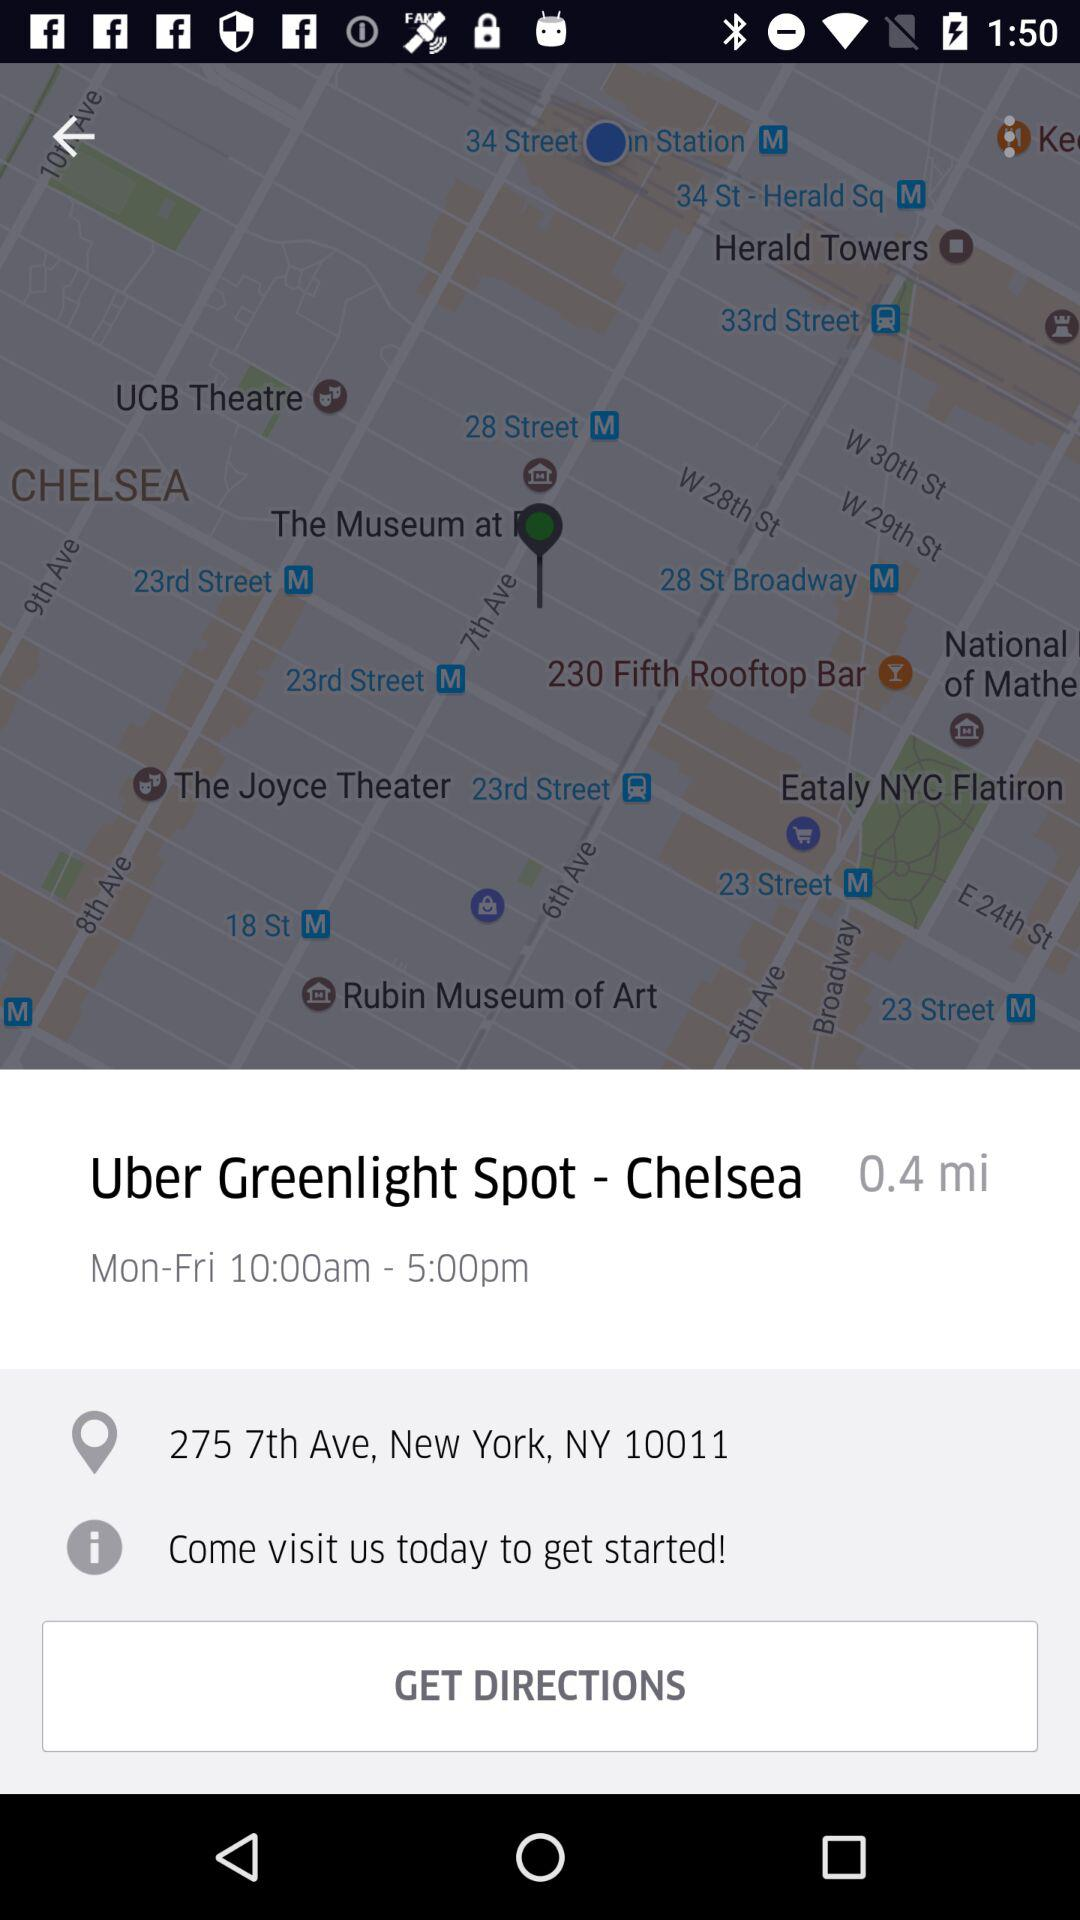How much is the distance? The distance is 0.4 miles. 